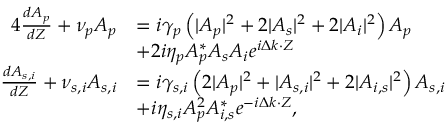<formula> <loc_0><loc_0><loc_500><loc_500>\begin{array} { r l } { { 4 } \frac { d A _ { p } } { d Z } + \nu _ { p } A _ { p } } & { = i \gamma _ { p } \left ( | A _ { p } | ^ { 2 } + 2 | A _ { s } | ^ { 2 } + 2 | A _ { i } | ^ { 2 } \right ) A _ { p } } \\ & { + 2 i \eta _ { p } A _ { p } ^ { * } A _ { s } A _ { i } e ^ { i \Delta k \cdot Z } } \\ { \frac { d A _ { s , i } } { d Z } + \nu _ { s , i } A _ { s , i } } & { = i \gamma _ { s , i } \left ( 2 | A _ { p } | ^ { 2 } + | A _ { s , i } | ^ { 2 } + 2 | A _ { i , s } | ^ { 2 } \right ) A _ { s , i } } \\ & { + i \eta _ { s , i } A _ { p } ^ { 2 } A _ { i , s } ^ { * } e ^ { - i \Delta k \cdot Z } , } \end{array}</formula> 